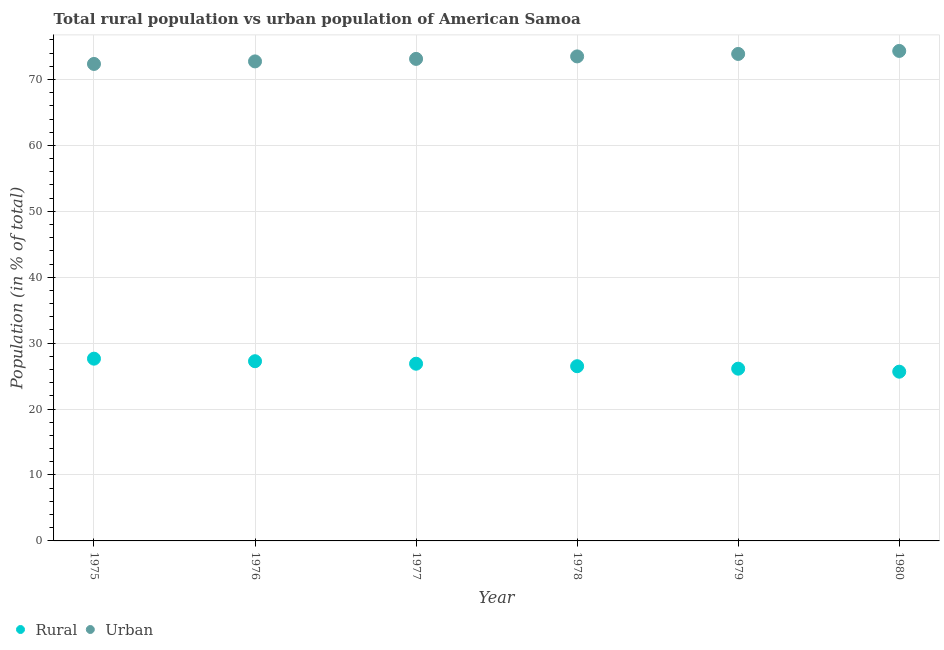How many different coloured dotlines are there?
Provide a succinct answer. 2. Is the number of dotlines equal to the number of legend labels?
Your response must be concise. Yes. What is the urban population in 1980?
Your answer should be very brief. 74.33. Across all years, what is the maximum rural population?
Keep it short and to the point. 27.65. Across all years, what is the minimum urban population?
Provide a short and direct response. 72.35. In which year was the rural population maximum?
Your response must be concise. 1975. In which year was the urban population minimum?
Provide a short and direct response. 1975. What is the total rural population in the graph?
Give a very brief answer. 160.09. What is the difference between the urban population in 1977 and that in 1980?
Your answer should be very brief. -1.21. What is the difference between the rural population in 1979 and the urban population in 1978?
Your response must be concise. -47.37. What is the average urban population per year?
Your response must be concise. 73.32. In the year 1975, what is the difference between the urban population and rural population?
Provide a short and direct response. 44.71. What is the ratio of the urban population in 1976 to that in 1979?
Ensure brevity in your answer.  0.98. Is the rural population in 1979 less than that in 1980?
Your answer should be compact. No. Is the difference between the urban population in 1977 and 1978 greater than the difference between the rural population in 1977 and 1978?
Keep it short and to the point. No. What is the difference between the highest and the second highest rural population?
Give a very brief answer. 0.39. What is the difference between the highest and the lowest urban population?
Your response must be concise. 1.98. In how many years, is the urban population greater than the average urban population taken over all years?
Keep it short and to the point. 3. Is the sum of the urban population in 1976 and 1977 greater than the maximum rural population across all years?
Your answer should be compact. Yes. Does the urban population monotonically increase over the years?
Your response must be concise. Yes. How many years are there in the graph?
Provide a succinct answer. 6. What is the difference between two consecutive major ticks on the Y-axis?
Ensure brevity in your answer.  10. Are the values on the major ticks of Y-axis written in scientific E-notation?
Provide a succinct answer. No. Does the graph contain grids?
Keep it short and to the point. Yes. What is the title of the graph?
Offer a terse response. Total rural population vs urban population of American Samoa. What is the label or title of the X-axis?
Provide a succinct answer. Year. What is the label or title of the Y-axis?
Your answer should be very brief. Population (in % of total). What is the Population (in % of total) of Rural in 1975?
Offer a very short reply. 27.65. What is the Population (in % of total) in Urban in 1975?
Offer a terse response. 72.35. What is the Population (in % of total) in Rural in 1976?
Give a very brief answer. 27.26. What is the Population (in % of total) in Urban in 1976?
Give a very brief answer. 72.74. What is the Population (in % of total) of Rural in 1977?
Offer a very short reply. 26.88. What is the Population (in % of total) of Urban in 1977?
Your answer should be very brief. 73.12. What is the Population (in % of total) of Rural in 1978?
Provide a succinct answer. 26.5. What is the Population (in % of total) in Urban in 1978?
Your answer should be compact. 73.5. What is the Population (in % of total) in Rural in 1979?
Provide a succinct answer. 26.13. What is the Population (in % of total) of Urban in 1979?
Offer a very short reply. 73.87. What is the Population (in % of total) of Rural in 1980?
Offer a terse response. 25.67. What is the Population (in % of total) in Urban in 1980?
Offer a terse response. 74.33. Across all years, what is the maximum Population (in % of total) of Rural?
Make the answer very short. 27.65. Across all years, what is the maximum Population (in % of total) of Urban?
Make the answer very short. 74.33. Across all years, what is the minimum Population (in % of total) of Rural?
Offer a terse response. 25.67. Across all years, what is the minimum Population (in % of total) of Urban?
Your answer should be very brief. 72.35. What is the total Population (in % of total) in Rural in the graph?
Keep it short and to the point. 160.09. What is the total Population (in % of total) in Urban in the graph?
Your answer should be compact. 439.91. What is the difference between the Population (in % of total) in Rural in 1975 and that in 1976?
Your answer should be very brief. 0.39. What is the difference between the Population (in % of total) of Urban in 1975 and that in 1976?
Offer a very short reply. -0.39. What is the difference between the Population (in % of total) of Rural in 1975 and that in 1977?
Keep it short and to the point. 0.77. What is the difference between the Population (in % of total) of Urban in 1975 and that in 1977?
Give a very brief answer. -0.77. What is the difference between the Population (in % of total) in Rural in 1975 and that in 1978?
Provide a succinct answer. 1.14. What is the difference between the Population (in % of total) of Urban in 1975 and that in 1978?
Make the answer very short. -1.14. What is the difference between the Population (in % of total) of Rural in 1975 and that in 1979?
Provide a succinct answer. 1.52. What is the difference between the Population (in % of total) in Urban in 1975 and that in 1979?
Keep it short and to the point. -1.52. What is the difference between the Population (in % of total) in Rural in 1975 and that in 1980?
Keep it short and to the point. 1.98. What is the difference between the Population (in % of total) of Urban in 1975 and that in 1980?
Offer a very short reply. -1.98. What is the difference between the Population (in % of total) of Rural in 1976 and that in 1977?
Ensure brevity in your answer.  0.38. What is the difference between the Population (in % of total) in Urban in 1976 and that in 1977?
Offer a terse response. -0.38. What is the difference between the Population (in % of total) in Rural in 1976 and that in 1978?
Ensure brevity in your answer.  0.76. What is the difference between the Population (in % of total) of Urban in 1976 and that in 1978?
Make the answer very short. -0.76. What is the difference between the Population (in % of total) in Rural in 1976 and that in 1979?
Ensure brevity in your answer.  1.13. What is the difference between the Population (in % of total) in Urban in 1976 and that in 1979?
Your response must be concise. -1.13. What is the difference between the Population (in % of total) of Rural in 1976 and that in 1980?
Make the answer very short. 1.59. What is the difference between the Population (in % of total) in Urban in 1976 and that in 1980?
Provide a short and direct response. -1.59. What is the difference between the Population (in % of total) of Rural in 1977 and that in 1978?
Ensure brevity in your answer.  0.38. What is the difference between the Population (in % of total) in Urban in 1977 and that in 1978?
Your answer should be compact. -0.38. What is the difference between the Population (in % of total) in Rural in 1977 and that in 1979?
Ensure brevity in your answer.  0.75. What is the difference between the Population (in % of total) in Urban in 1977 and that in 1979?
Keep it short and to the point. -0.75. What is the difference between the Population (in % of total) in Rural in 1977 and that in 1980?
Keep it short and to the point. 1.21. What is the difference between the Population (in % of total) in Urban in 1977 and that in 1980?
Provide a short and direct response. -1.21. What is the difference between the Population (in % of total) in Rural in 1978 and that in 1979?
Give a very brief answer. 0.37. What is the difference between the Population (in % of total) of Urban in 1978 and that in 1979?
Offer a terse response. -0.37. What is the difference between the Population (in % of total) of Rural in 1978 and that in 1980?
Offer a terse response. 0.83. What is the difference between the Population (in % of total) of Urban in 1978 and that in 1980?
Offer a terse response. -0.83. What is the difference between the Population (in % of total) in Rural in 1979 and that in 1980?
Your answer should be compact. 0.46. What is the difference between the Population (in % of total) in Urban in 1979 and that in 1980?
Ensure brevity in your answer.  -0.46. What is the difference between the Population (in % of total) of Rural in 1975 and the Population (in % of total) of Urban in 1976?
Provide a short and direct response. -45.09. What is the difference between the Population (in % of total) of Rural in 1975 and the Population (in % of total) of Urban in 1977?
Your answer should be very brief. -45.47. What is the difference between the Population (in % of total) of Rural in 1975 and the Population (in % of total) of Urban in 1978?
Provide a succinct answer. -45.85. What is the difference between the Population (in % of total) in Rural in 1975 and the Population (in % of total) in Urban in 1979?
Give a very brief answer. -46.23. What is the difference between the Population (in % of total) in Rural in 1975 and the Population (in % of total) in Urban in 1980?
Provide a succinct answer. -46.68. What is the difference between the Population (in % of total) of Rural in 1976 and the Population (in % of total) of Urban in 1977?
Offer a very short reply. -45.86. What is the difference between the Population (in % of total) in Rural in 1976 and the Population (in % of total) in Urban in 1978?
Your answer should be compact. -46.24. What is the difference between the Population (in % of total) in Rural in 1976 and the Population (in % of total) in Urban in 1979?
Provide a succinct answer. -46.61. What is the difference between the Population (in % of total) in Rural in 1976 and the Population (in % of total) in Urban in 1980?
Offer a terse response. -47.07. What is the difference between the Population (in % of total) in Rural in 1977 and the Population (in % of total) in Urban in 1978?
Make the answer very short. -46.62. What is the difference between the Population (in % of total) of Rural in 1977 and the Population (in % of total) of Urban in 1979?
Give a very brief answer. -46.99. What is the difference between the Population (in % of total) of Rural in 1977 and the Population (in % of total) of Urban in 1980?
Your answer should be compact. -47.45. What is the difference between the Population (in % of total) of Rural in 1978 and the Population (in % of total) of Urban in 1979?
Keep it short and to the point. -47.37. What is the difference between the Population (in % of total) of Rural in 1978 and the Population (in % of total) of Urban in 1980?
Provide a short and direct response. -47.83. What is the difference between the Population (in % of total) in Rural in 1979 and the Population (in % of total) in Urban in 1980?
Offer a terse response. -48.2. What is the average Population (in % of total) in Rural per year?
Make the answer very short. 26.68. What is the average Population (in % of total) in Urban per year?
Your answer should be very brief. 73.32. In the year 1975, what is the difference between the Population (in % of total) of Rural and Population (in % of total) of Urban?
Make the answer very short. -44.71. In the year 1976, what is the difference between the Population (in % of total) of Rural and Population (in % of total) of Urban?
Your answer should be compact. -45.48. In the year 1977, what is the difference between the Population (in % of total) of Rural and Population (in % of total) of Urban?
Offer a very short reply. -46.24. In the year 1978, what is the difference between the Population (in % of total) of Rural and Population (in % of total) of Urban?
Provide a short and direct response. -46.99. In the year 1979, what is the difference between the Population (in % of total) of Rural and Population (in % of total) of Urban?
Offer a very short reply. -47.74. In the year 1980, what is the difference between the Population (in % of total) of Rural and Population (in % of total) of Urban?
Your answer should be compact. -48.66. What is the ratio of the Population (in % of total) of Rural in 1975 to that in 1976?
Your answer should be compact. 1.01. What is the ratio of the Population (in % of total) in Urban in 1975 to that in 1976?
Your answer should be compact. 0.99. What is the ratio of the Population (in % of total) in Rural in 1975 to that in 1977?
Ensure brevity in your answer.  1.03. What is the ratio of the Population (in % of total) in Rural in 1975 to that in 1978?
Keep it short and to the point. 1.04. What is the ratio of the Population (in % of total) in Urban in 1975 to that in 1978?
Ensure brevity in your answer.  0.98. What is the ratio of the Population (in % of total) of Rural in 1975 to that in 1979?
Keep it short and to the point. 1.06. What is the ratio of the Population (in % of total) of Urban in 1975 to that in 1979?
Offer a very short reply. 0.98. What is the ratio of the Population (in % of total) of Rural in 1975 to that in 1980?
Provide a short and direct response. 1.08. What is the ratio of the Population (in % of total) of Urban in 1975 to that in 1980?
Keep it short and to the point. 0.97. What is the ratio of the Population (in % of total) of Rural in 1976 to that in 1977?
Your response must be concise. 1.01. What is the ratio of the Population (in % of total) of Urban in 1976 to that in 1977?
Provide a succinct answer. 0.99. What is the ratio of the Population (in % of total) in Rural in 1976 to that in 1978?
Ensure brevity in your answer.  1.03. What is the ratio of the Population (in % of total) of Urban in 1976 to that in 1978?
Give a very brief answer. 0.99. What is the ratio of the Population (in % of total) of Rural in 1976 to that in 1979?
Give a very brief answer. 1.04. What is the ratio of the Population (in % of total) in Urban in 1976 to that in 1979?
Your answer should be compact. 0.98. What is the ratio of the Population (in % of total) in Rural in 1976 to that in 1980?
Your response must be concise. 1.06. What is the ratio of the Population (in % of total) in Urban in 1976 to that in 1980?
Keep it short and to the point. 0.98. What is the ratio of the Population (in % of total) in Rural in 1977 to that in 1978?
Offer a terse response. 1.01. What is the ratio of the Population (in % of total) in Urban in 1977 to that in 1978?
Your response must be concise. 0.99. What is the ratio of the Population (in % of total) in Rural in 1977 to that in 1979?
Offer a very short reply. 1.03. What is the ratio of the Population (in % of total) of Urban in 1977 to that in 1979?
Give a very brief answer. 0.99. What is the ratio of the Population (in % of total) of Rural in 1977 to that in 1980?
Your response must be concise. 1.05. What is the ratio of the Population (in % of total) in Urban in 1977 to that in 1980?
Offer a very short reply. 0.98. What is the ratio of the Population (in % of total) of Rural in 1978 to that in 1979?
Offer a very short reply. 1.01. What is the ratio of the Population (in % of total) of Rural in 1978 to that in 1980?
Your answer should be compact. 1.03. What is the ratio of the Population (in % of total) of Rural in 1979 to that in 1980?
Your response must be concise. 1.02. What is the difference between the highest and the second highest Population (in % of total) of Rural?
Your answer should be very brief. 0.39. What is the difference between the highest and the second highest Population (in % of total) in Urban?
Your response must be concise. 0.46. What is the difference between the highest and the lowest Population (in % of total) of Rural?
Offer a terse response. 1.98. What is the difference between the highest and the lowest Population (in % of total) of Urban?
Ensure brevity in your answer.  1.98. 